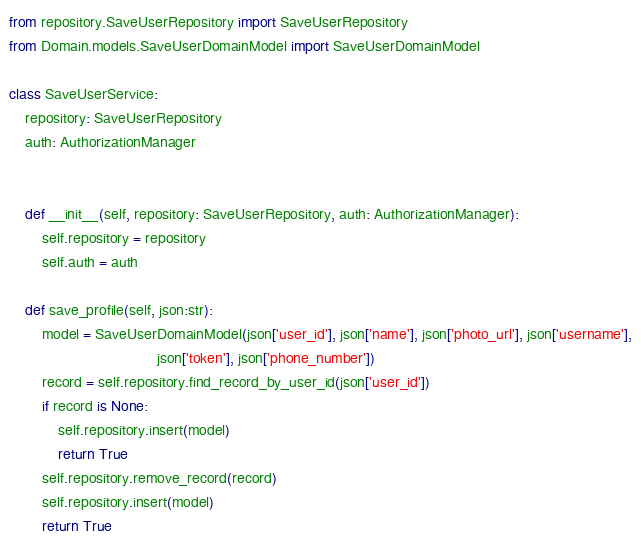Convert code to text. <code><loc_0><loc_0><loc_500><loc_500><_Python_>from repository.SaveUserRepository import SaveUserRepository
from Domain.models.SaveUserDomainModel import SaveUserDomainModel

class SaveUserService:
    repository: SaveUserRepository
    auth: AuthorizationManager


    def __init__(self, repository: SaveUserRepository, auth: AuthorizationManager):
        self.repository = repository
        self.auth = auth

    def save_profile(self, json:str):
        model = SaveUserDomainModel(json['user_id'], json['name'], json['photo_url'], json['username'],
                                    json['token'], json['phone_number'])
        record = self.repository.find_record_by_user_id(json['user_id'])
        if record is None:
            self.repository.insert(model)
            return True
        self.repository.remove_record(record)
        self.repository.insert(model)
        return True


</code> 